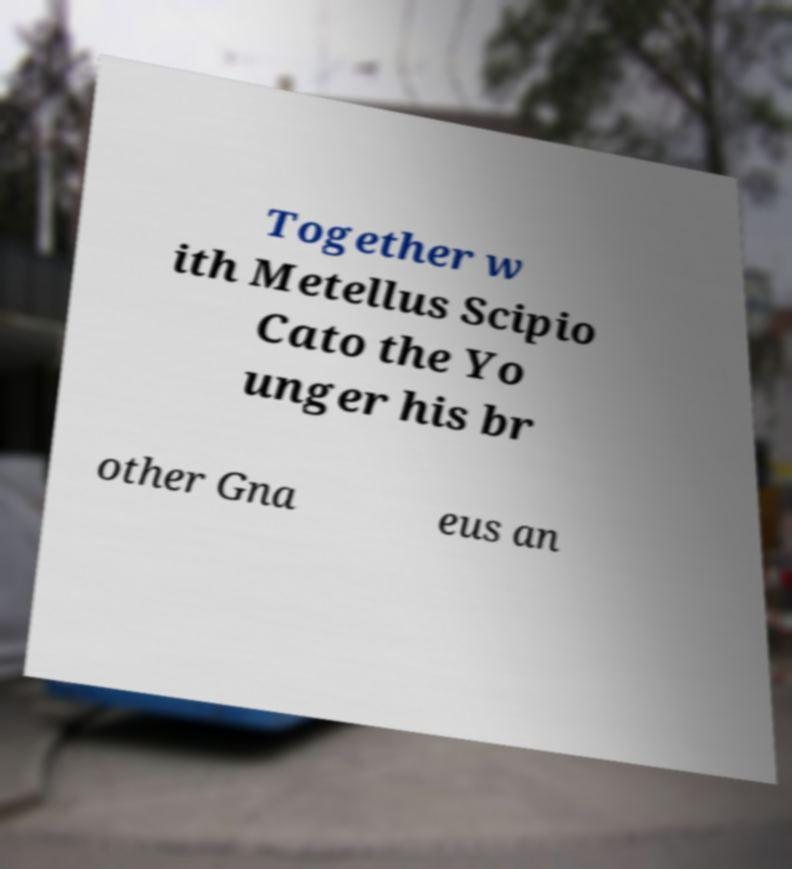Please read and relay the text visible in this image. What does it say? Together w ith Metellus Scipio Cato the Yo unger his br other Gna eus an 